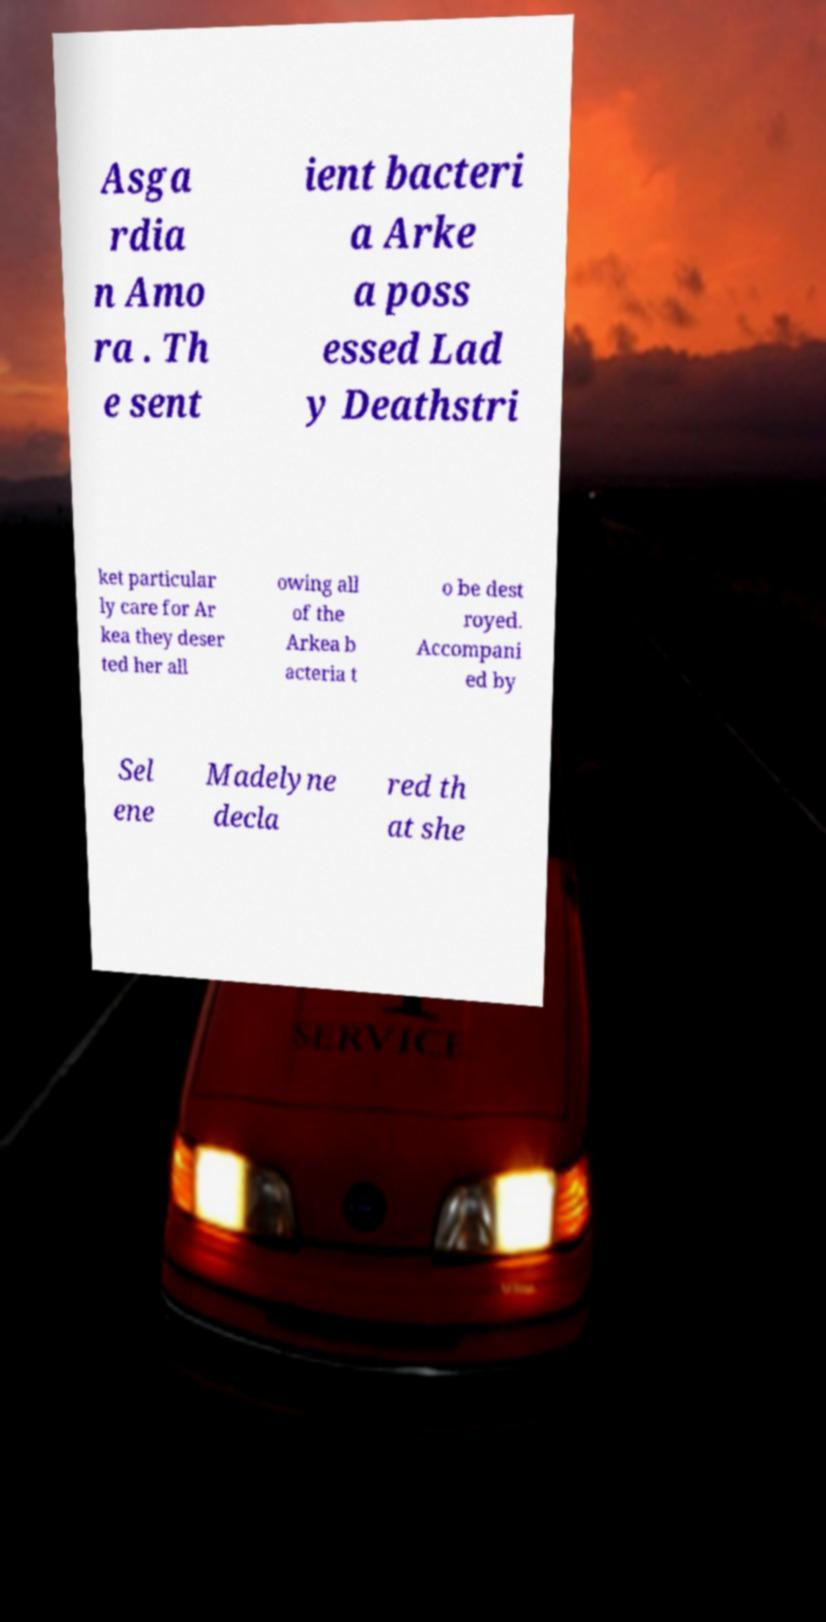Could you extract and type out the text from this image? Asga rdia n Amo ra . Th e sent ient bacteri a Arke a poss essed Lad y Deathstri ket particular ly care for Ar kea they deser ted her all owing all of the Arkea b acteria t o be dest royed. Accompani ed by Sel ene Madelyne decla red th at she 